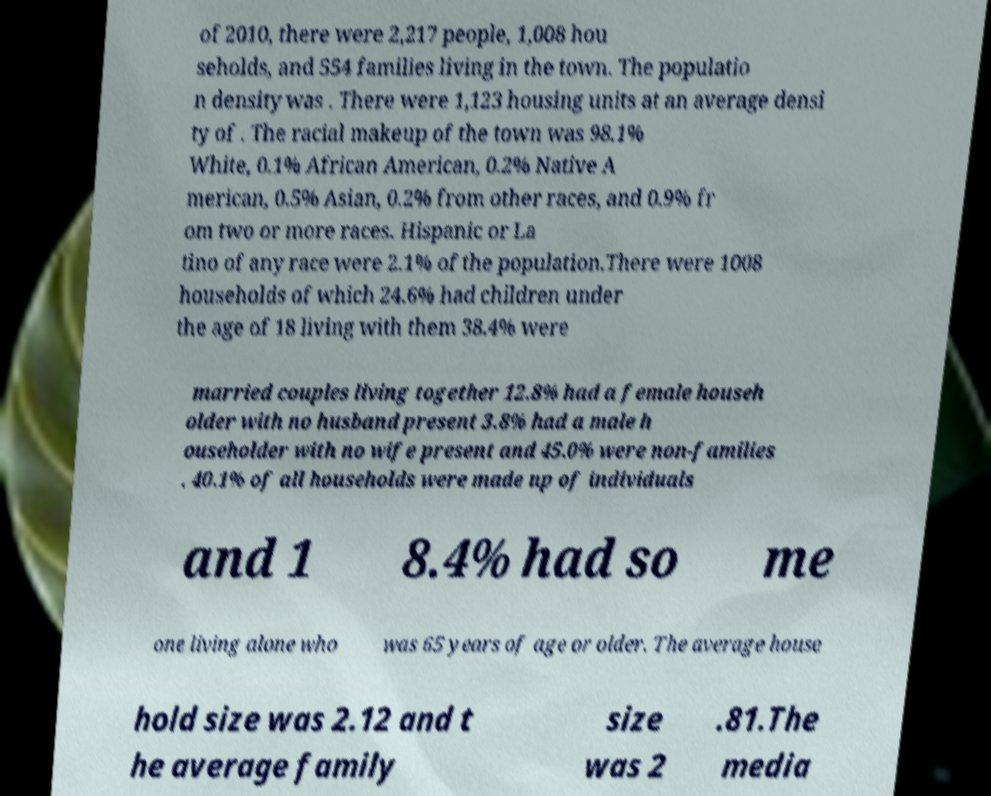For documentation purposes, I need the text within this image transcribed. Could you provide that? of 2010, there were 2,217 people, 1,008 hou seholds, and 554 families living in the town. The populatio n density was . There were 1,123 housing units at an average densi ty of . The racial makeup of the town was 98.1% White, 0.1% African American, 0.2% Native A merican, 0.5% Asian, 0.2% from other races, and 0.9% fr om two or more races. Hispanic or La tino of any race were 2.1% of the population.There were 1008 households of which 24.6% had children under the age of 18 living with them 38.4% were married couples living together 12.8% had a female househ older with no husband present 3.8% had a male h ouseholder with no wife present and 45.0% were non-families . 40.1% of all households were made up of individuals and 1 8.4% had so me one living alone who was 65 years of age or older. The average house hold size was 2.12 and t he average family size was 2 .81.The media 